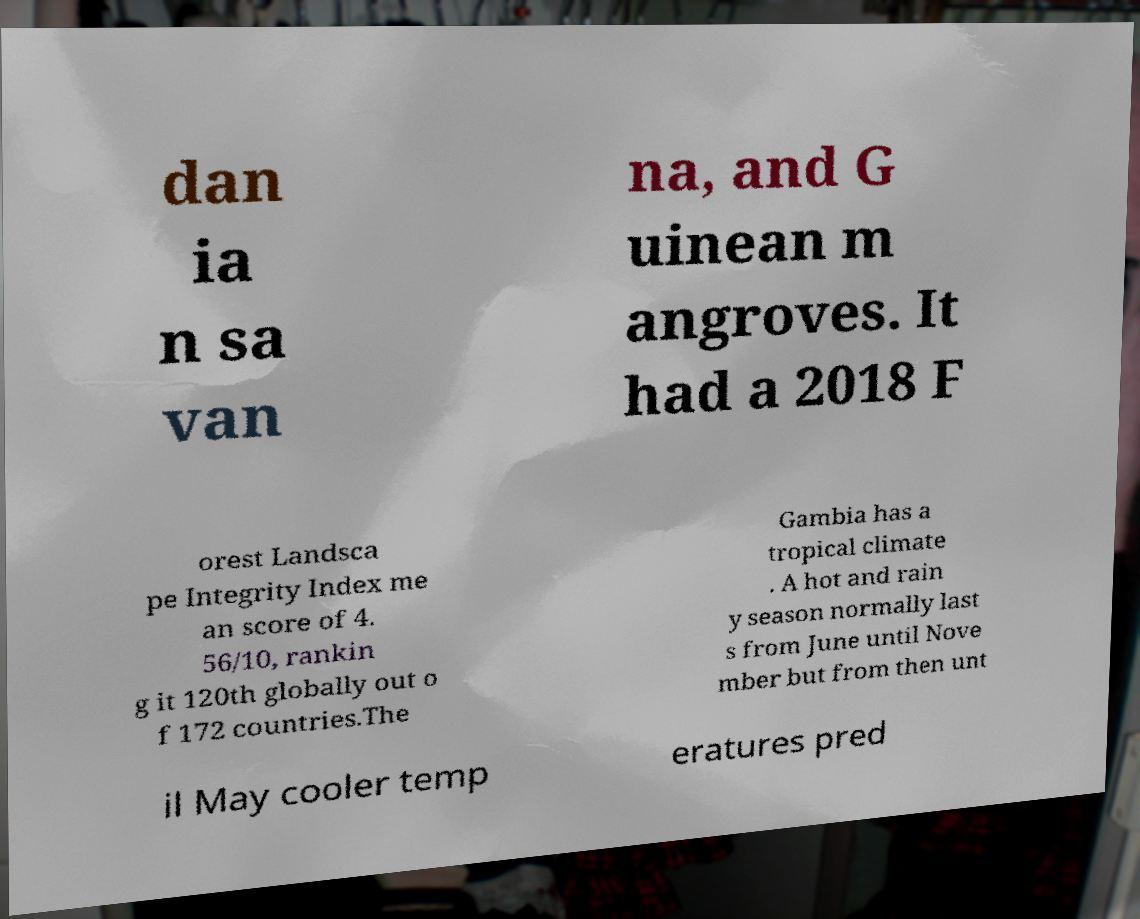Can you read and provide the text displayed in the image?This photo seems to have some interesting text. Can you extract and type it out for me? dan ia n sa van na, and G uinean m angroves. It had a 2018 F orest Landsca pe Integrity Index me an score of 4. 56/10, rankin g it 120th globally out o f 172 countries.The Gambia has a tropical climate . A hot and rain y season normally last s from June until Nove mber but from then unt il May cooler temp eratures pred 